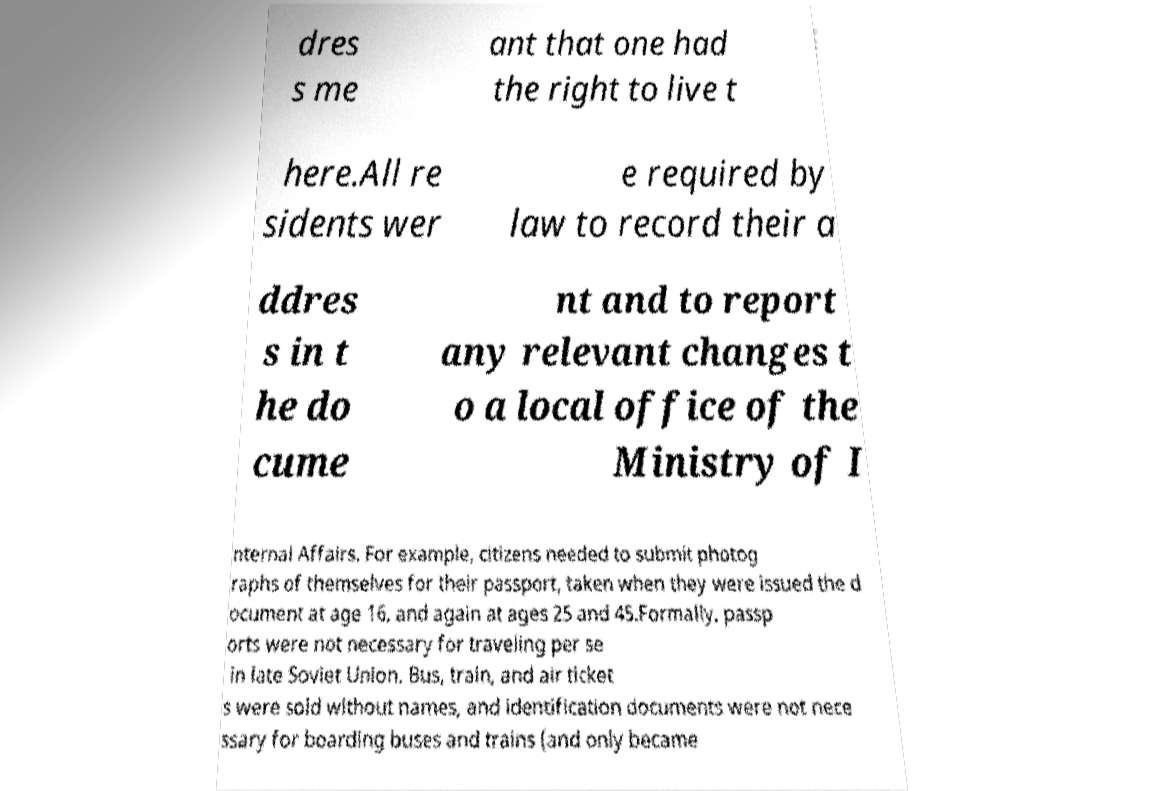Please identify and transcribe the text found in this image. dres s me ant that one had the right to live t here.All re sidents wer e required by law to record their a ddres s in t he do cume nt and to report any relevant changes t o a local office of the Ministry of I nternal Affairs. For example, citizens needed to submit photog raphs of themselves for their passport, taken when they were issued the d ocument at age 16, and again at ages 25 and 45.Formally, passp orts were not necessary for traveling per se in late Soviet Union. Bus, train, and air ticket s were sold without names, and identification documents were not nece ssary for boarding buses and trains (and only became 